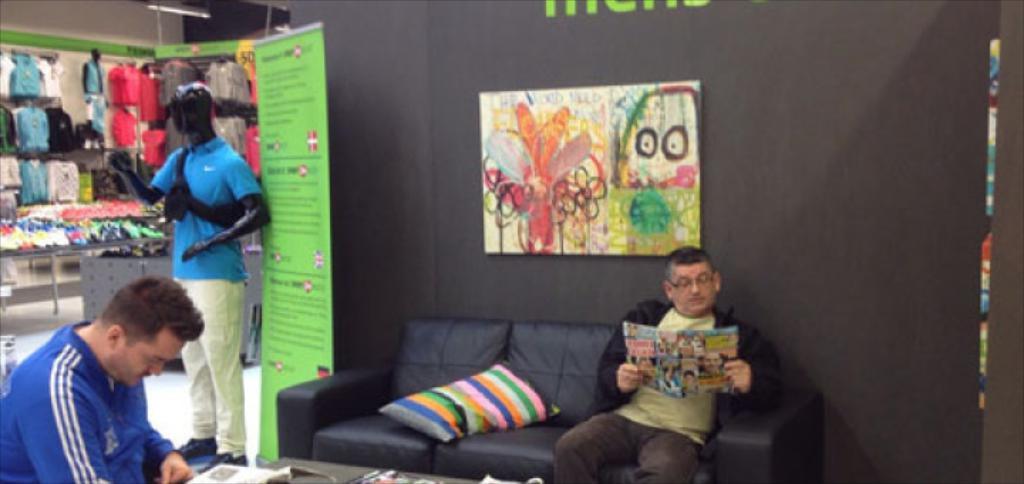Describe this image in one or two sentences. A couch with pillow. Person is sitting on a couch and holds paper. This is a banner. Poster on wall. Mannequin. Person is sitting. This are clothes. 